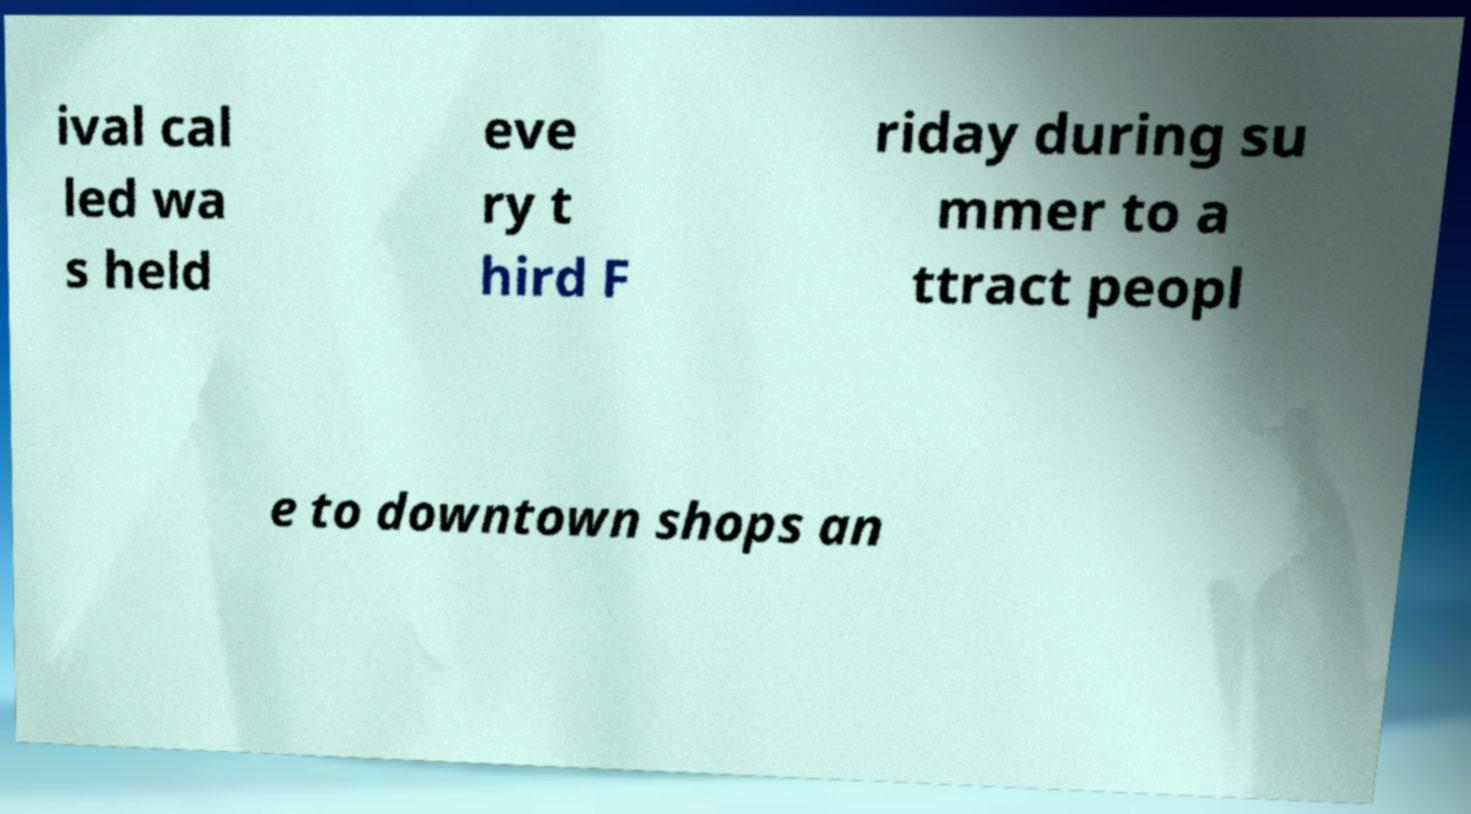Could you assist in decoding the text presented in this image and type it out clearly? ival cal led wa s held eve ry t hird F riday during su mmer to a ttract peopl e to downtown shops an 